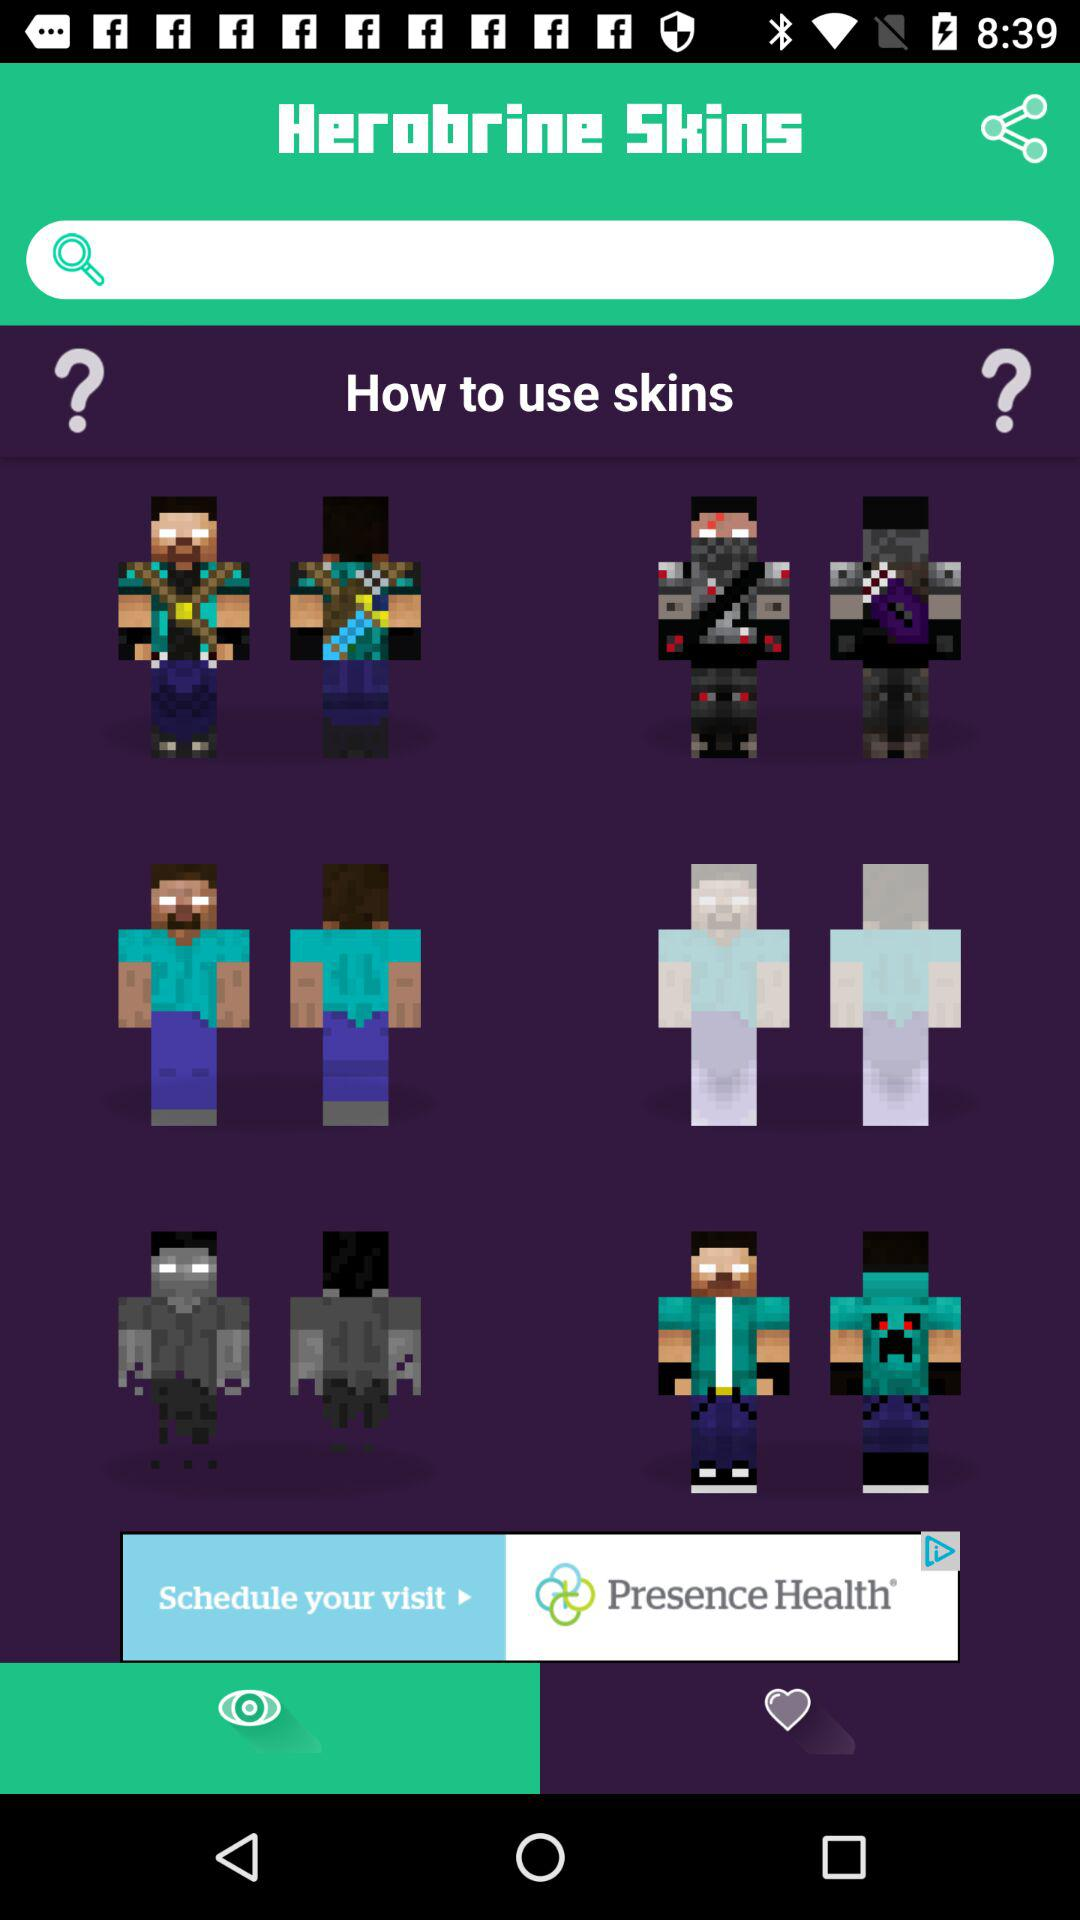Which tab am I on?
When the provided information is insufficient, respond with <no answer>. <no answer> 